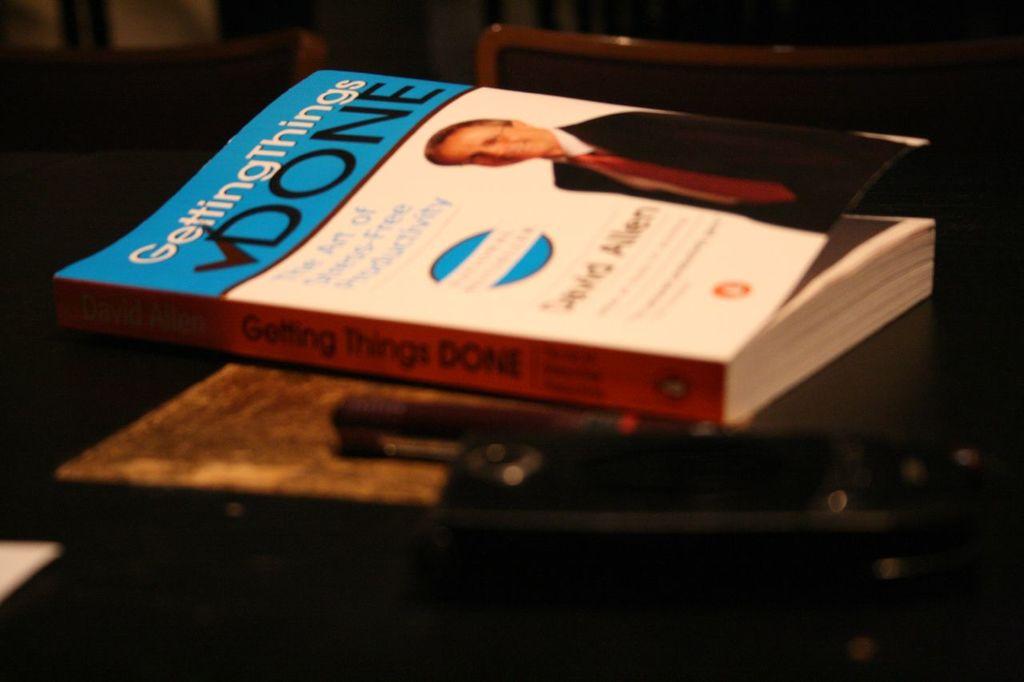Is that an self motivation or self help book, you are reading?
Your answer should be compact. Yes. What is the title?
Offer a very short reply. Getting things done. 